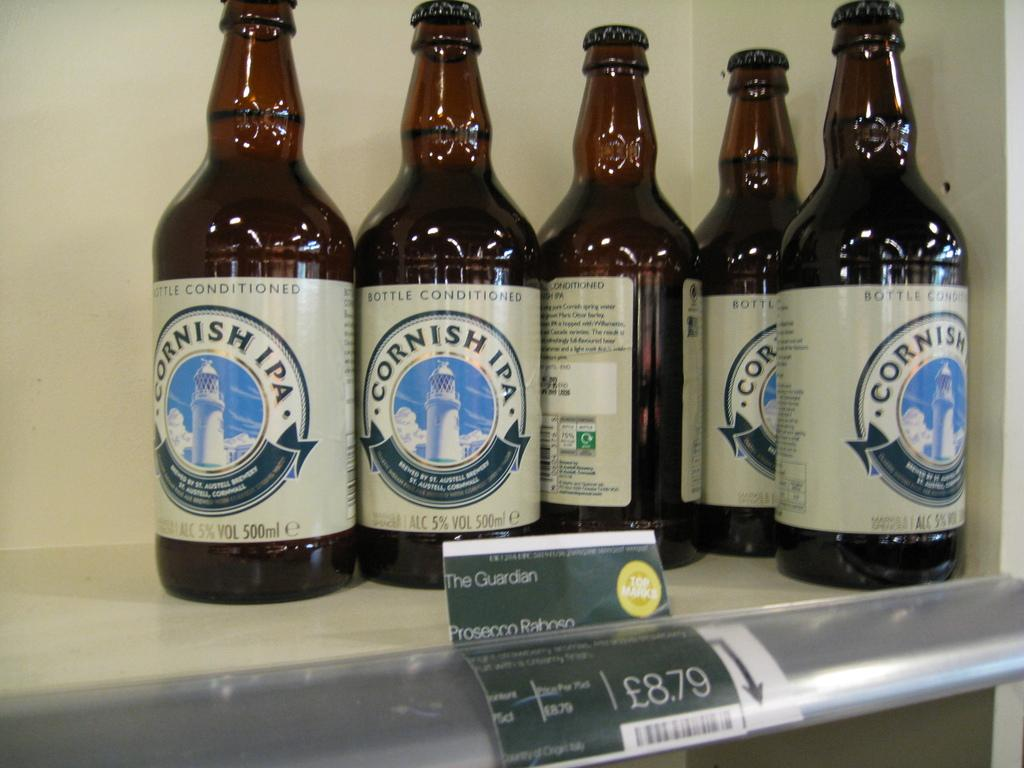<image>
Create a compact narrative representing the image presented. Five bottles of Cornish IPA sit on a store shelf. 